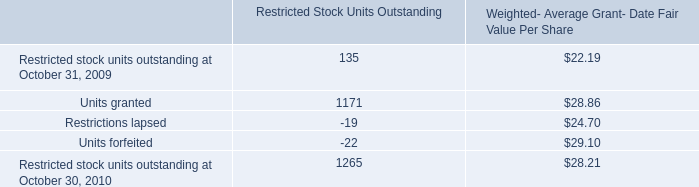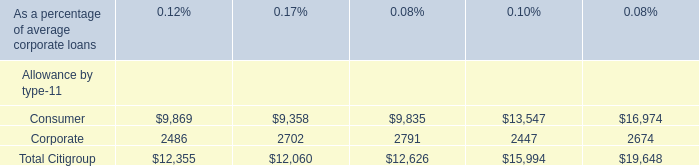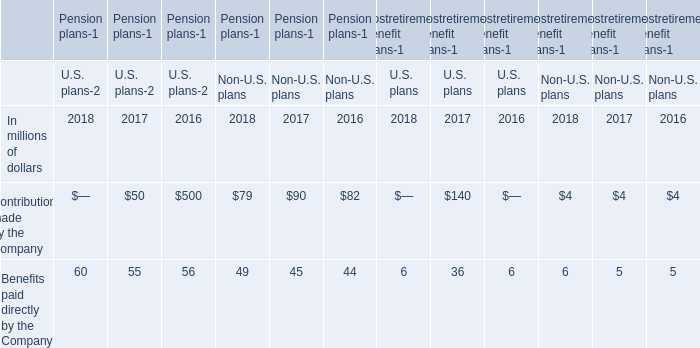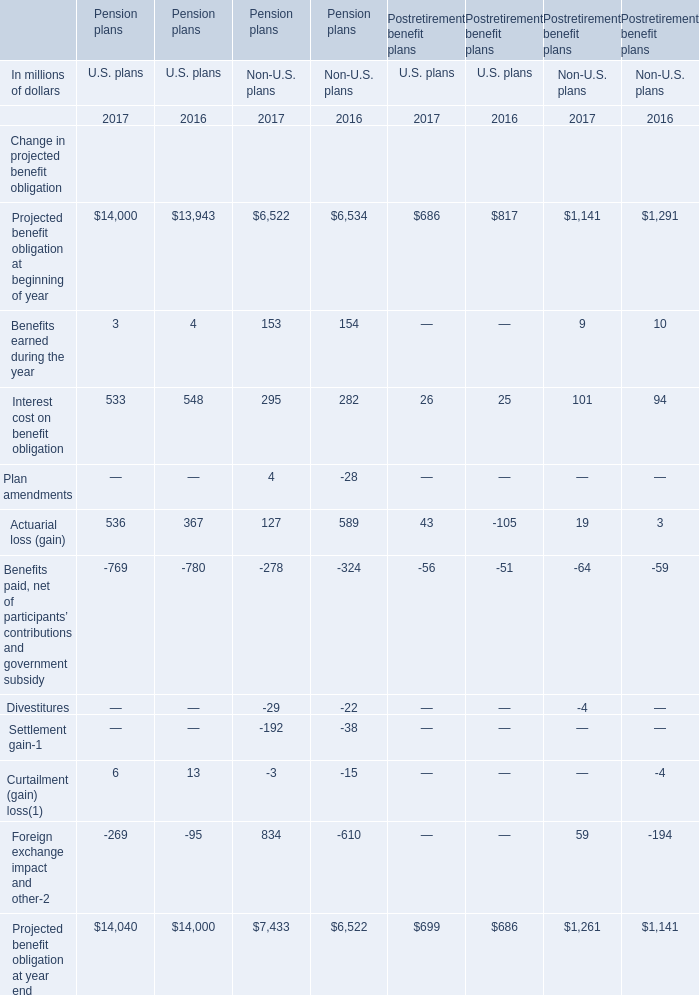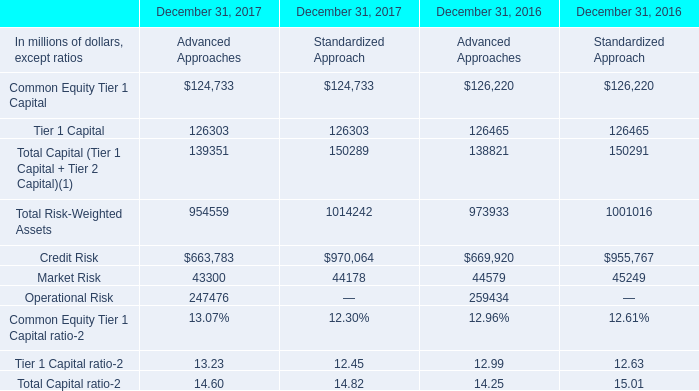If Benefits paid directly by the Company develops with the same growth rate in 2017, what will it reach in 2018 for U.S. plans ? (in million) 
Computations: (60 * (1 + ((60 - 55) / 55)))
Answer: 65.45455. 